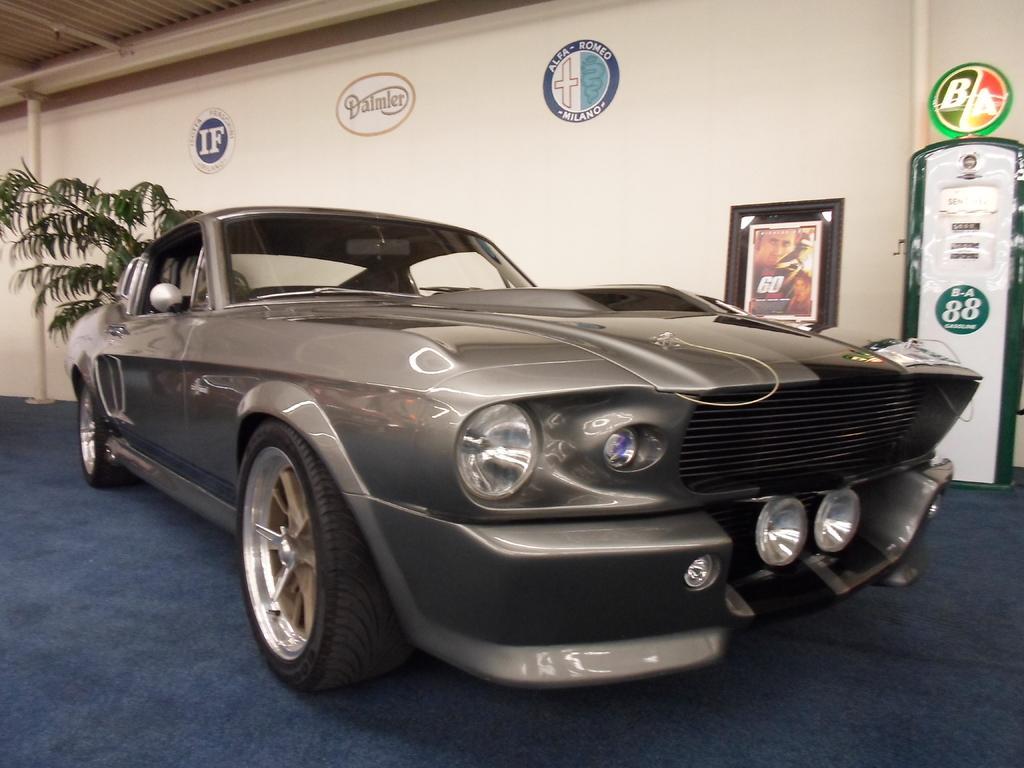How would you summarize this image in a sentence or two? In this picture there is a car on the blue color carpet. On the left there is a plant near to the wall. On the top left corner we can see roof of the building. On the right there is a machine and photo frame. Here we can see pipe. 